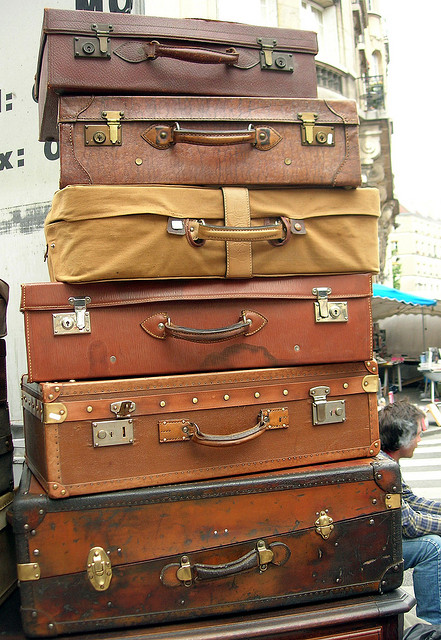Could these suitcases serve any purpose other than travel? Absolutely! Besides their primary function in travel, suitcases like these can be repurposed for creative home decor, storage solutions, or even as unique furniture pieces, such as side tables or shelving when stacked like this. 